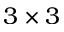Convert formula to latex. <formula><loc_0><loc_0><loc_500><loc_500>3 \times 3</formula> 